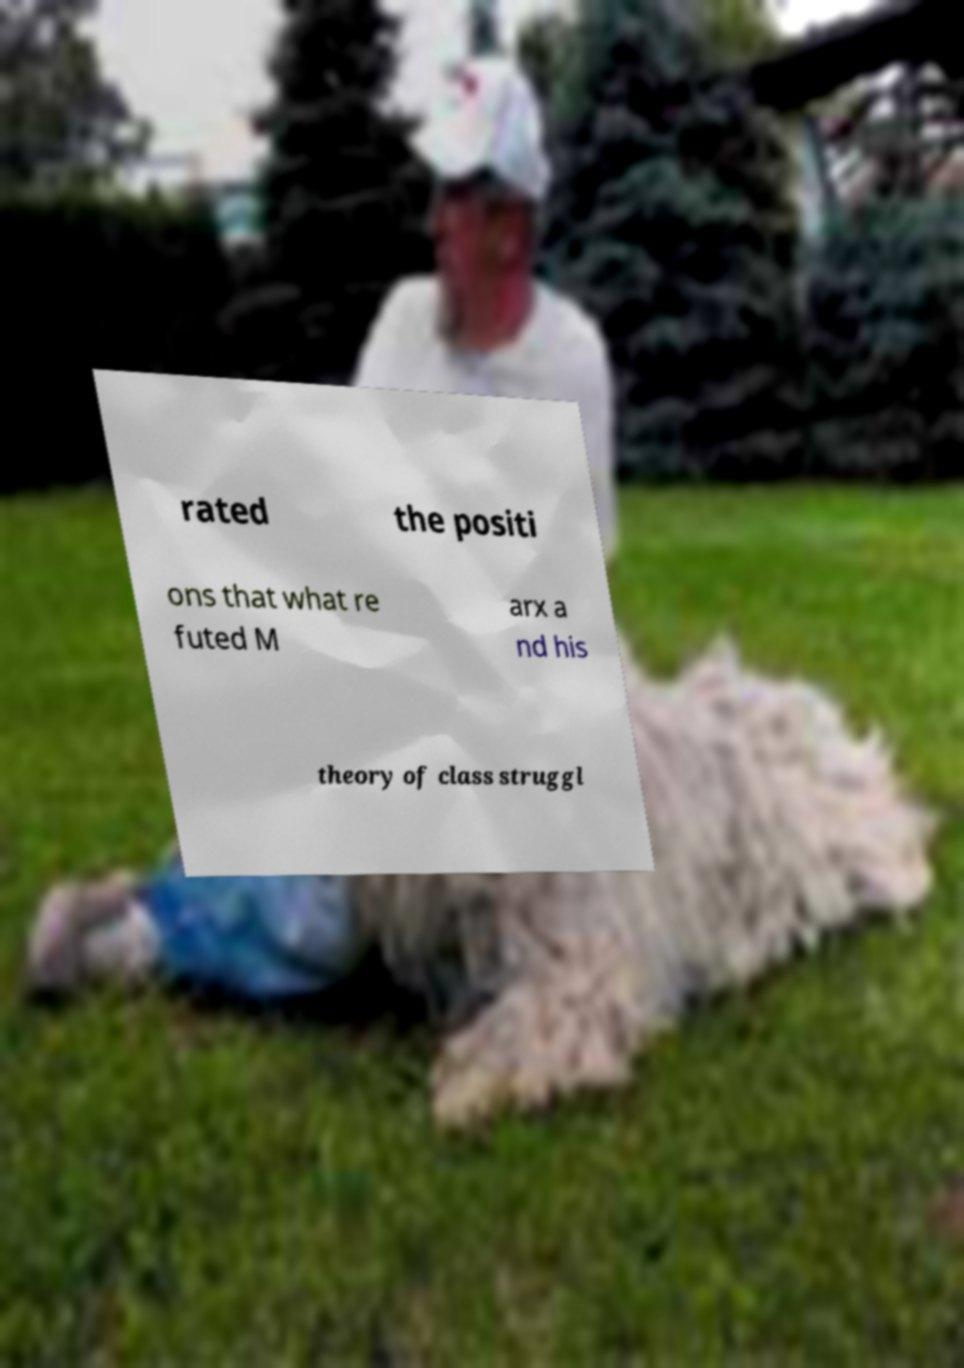Could you extract and type out the text from this image? rated the positi ons that what re futed M arx a nd his theory of class struggl 